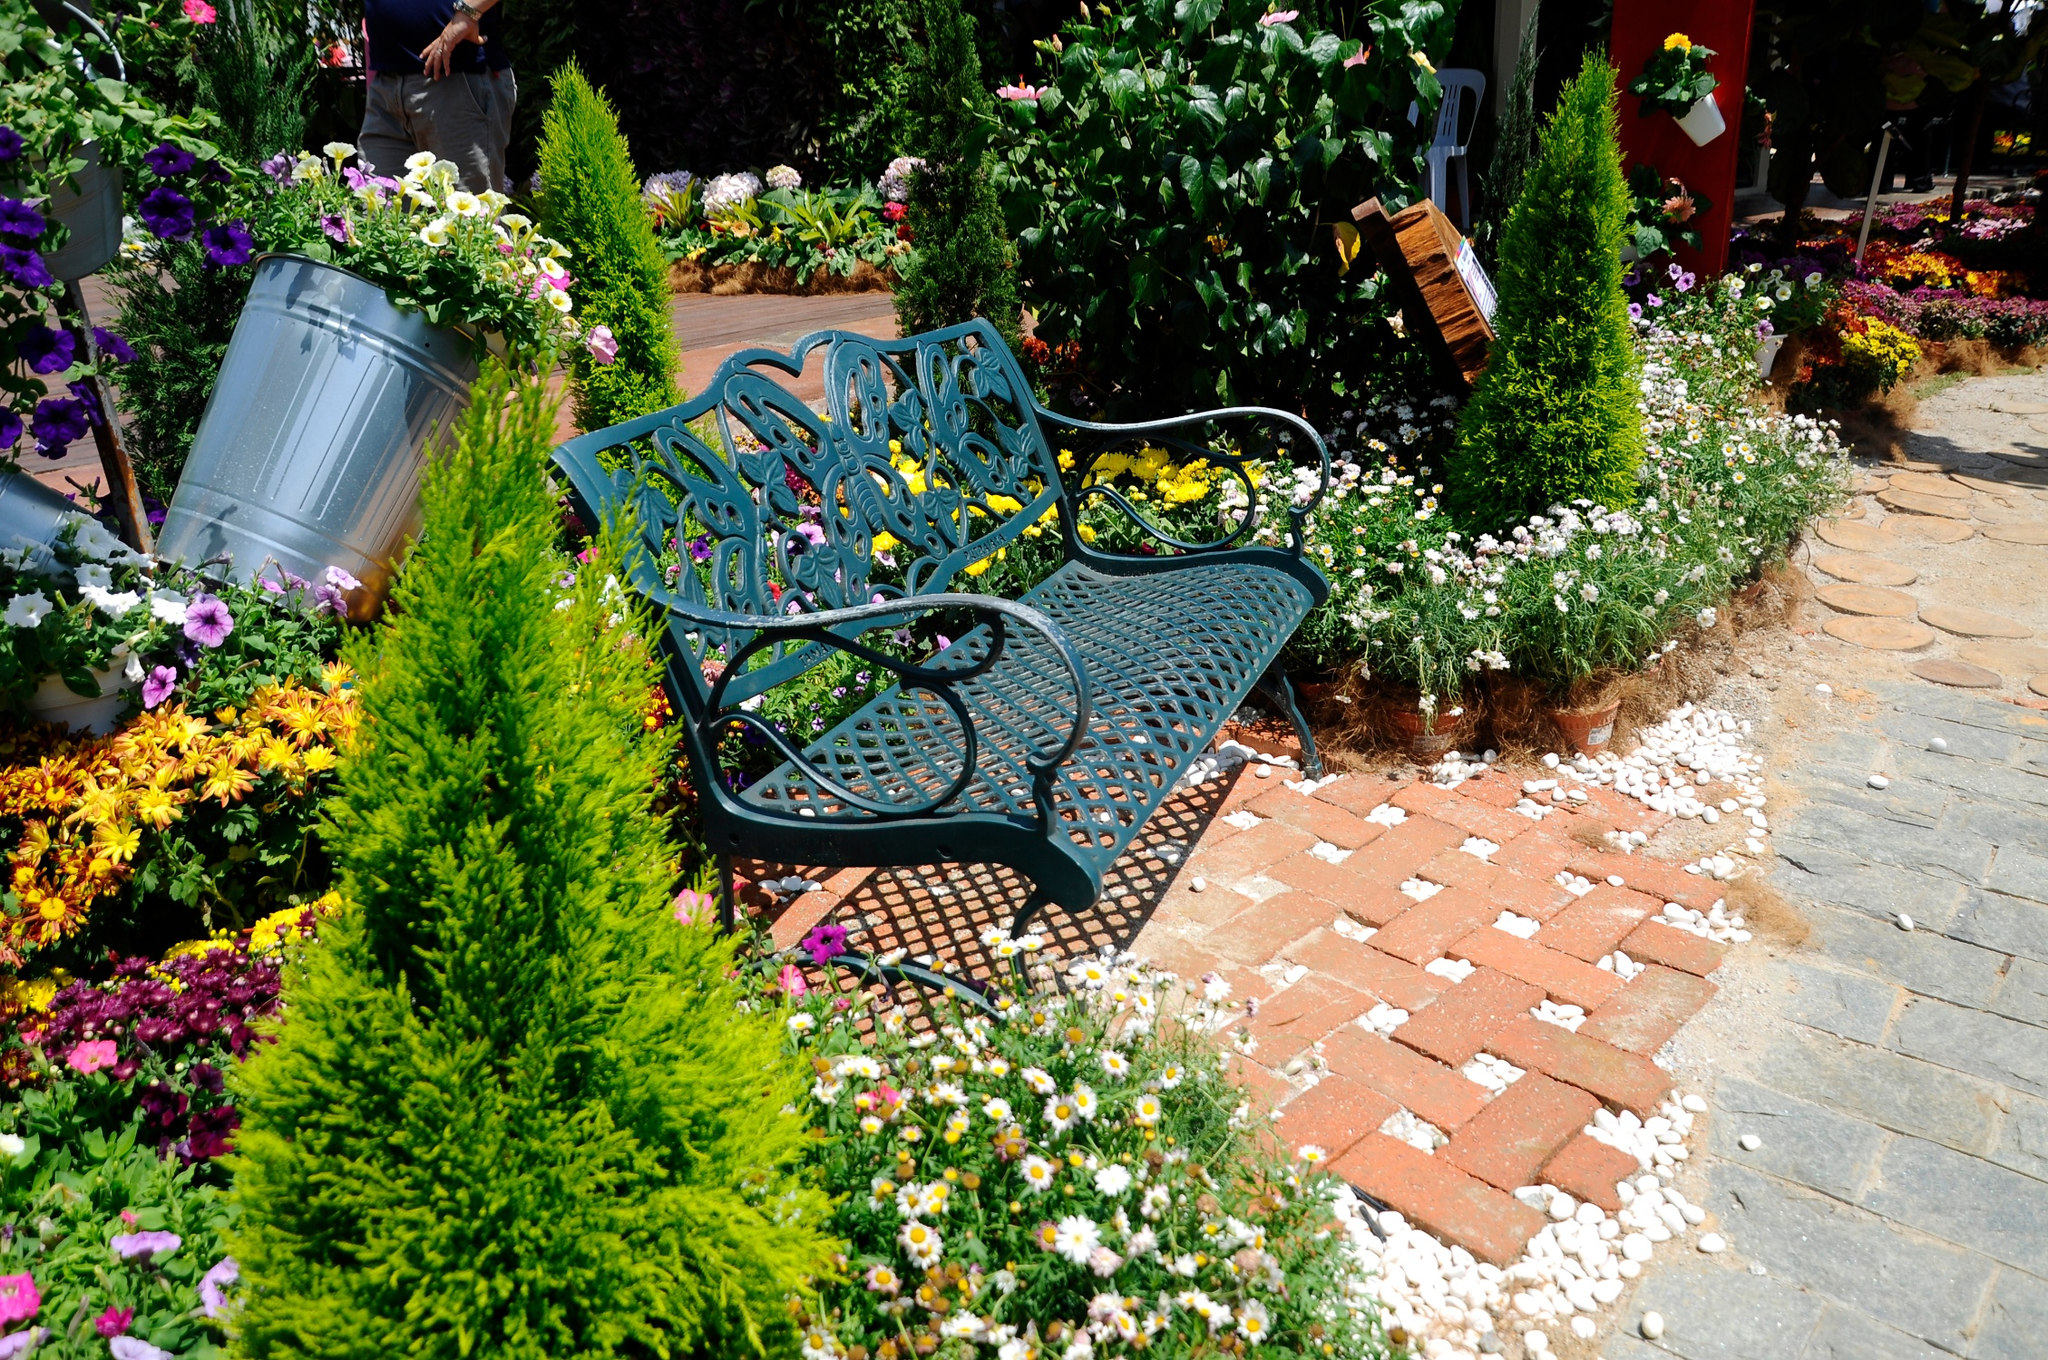Imagine this bench as a gateway to another world. What kind of world would it lead to? Imagine sitting on this bench and feeling a gentle pull, as if the very fabric of reality is shifting. Suddenly, the garden around you starts to transform. The flowers bloom brighter, their colors more vibrant than ever. The ground beneath your feet turns to a shimmering golden path, leading to a magical realm. This new world is one of enchantment—towering trees with golden leaves, rivers flowing with crystal-clear water that glows softly under the moonlight, and mythical creatures like unicorns and fairies frolicking peacefully. The air is filled with an ethereal music, and everywhere you look, there's an element of fantasy coming to life. This bench, now a portal, has transported you to a place where time stands still, and the wonders of the imagination are boundless. If this garden were part of a historical narrative, what kind of stories would it hold? If this garden were steeped in history, it would be a repository of countless tales. Perhaps, it was once part of an ancient royal palace, where kings and queens would stroll and discuss matters of state. It might have been a secret meeting spot for lovers, exchanging sweet nothings under the cover of night. The bench could have hosted renowned poets and artists, seeking inspiration from the tranquil beauty around them. Over the centuries, it witnessed revolutions, solemn reflections, and celebrations of life. Each flower and pebble holds a story of joy, sorrow, triumph, and love, making this garden not just a place of beauty but a silent storyteller of a rich and varied past. 